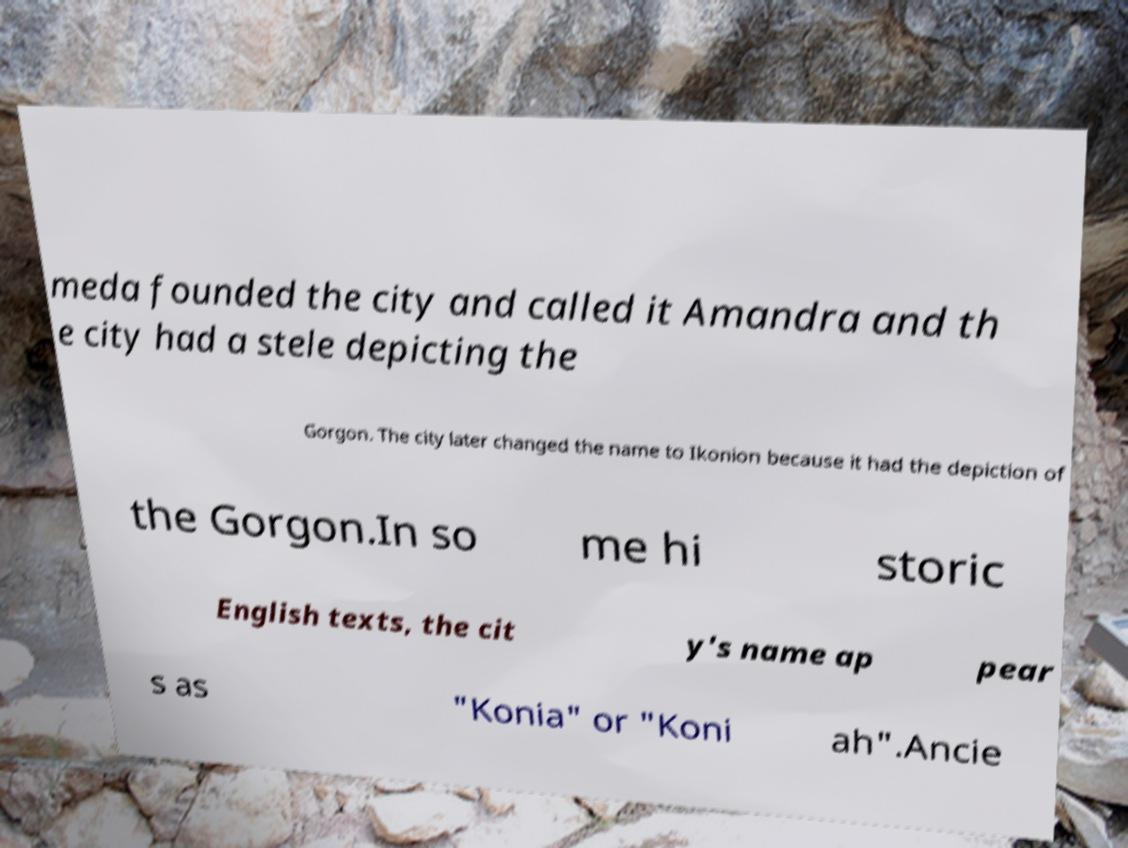Could you assist in decoding the text presented in this image and type it out clearly? meda founded the city and called it Amandra and th e city had a stele depicting the Gorgon. The city later changed the name to Ikonion because it had the depiction of the Gorgon.In so me hi storic English texts, the cit y's name ap pear s as "Konia" or "Koni ah".Ancie 